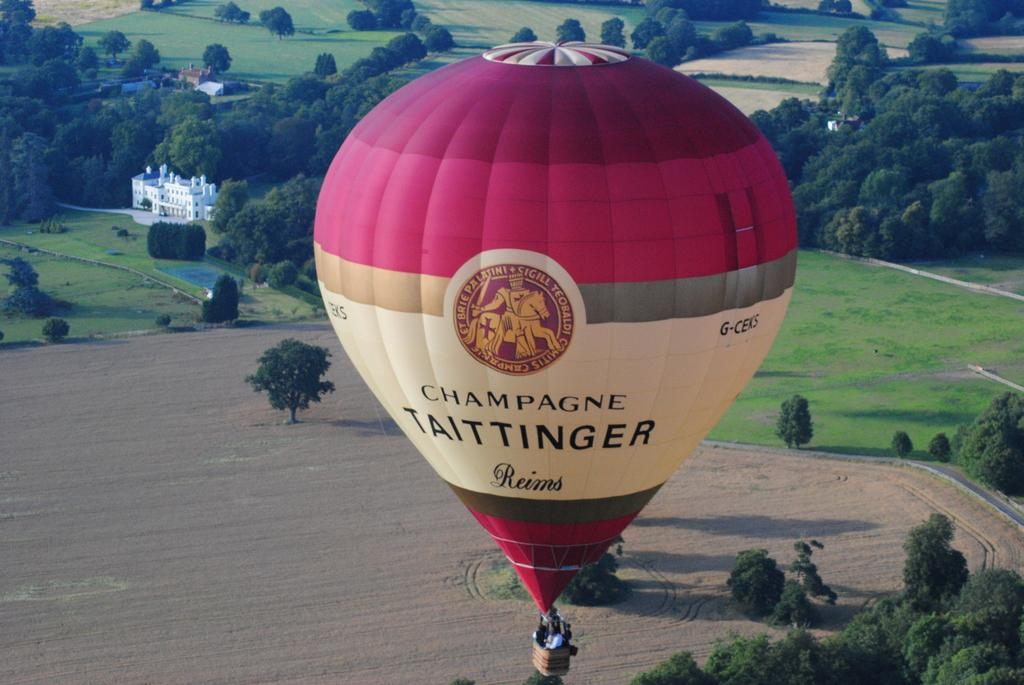What is the main subject of the image? The main subject of the image is a group of people. Where are the people located in the image? The people are in a hot air balloon. What type of basket is attached to the hot air balloon? The hot air balloon has a wicker basket. What can be seen in the background of the image? There are houses and trees in the background of the image. What type of honey is being produced by the sheep in the image? There are no sheep or honey present in the image; it features a group of people in a hot air balloon with a wicker basket, and the background includes houses and trees. 